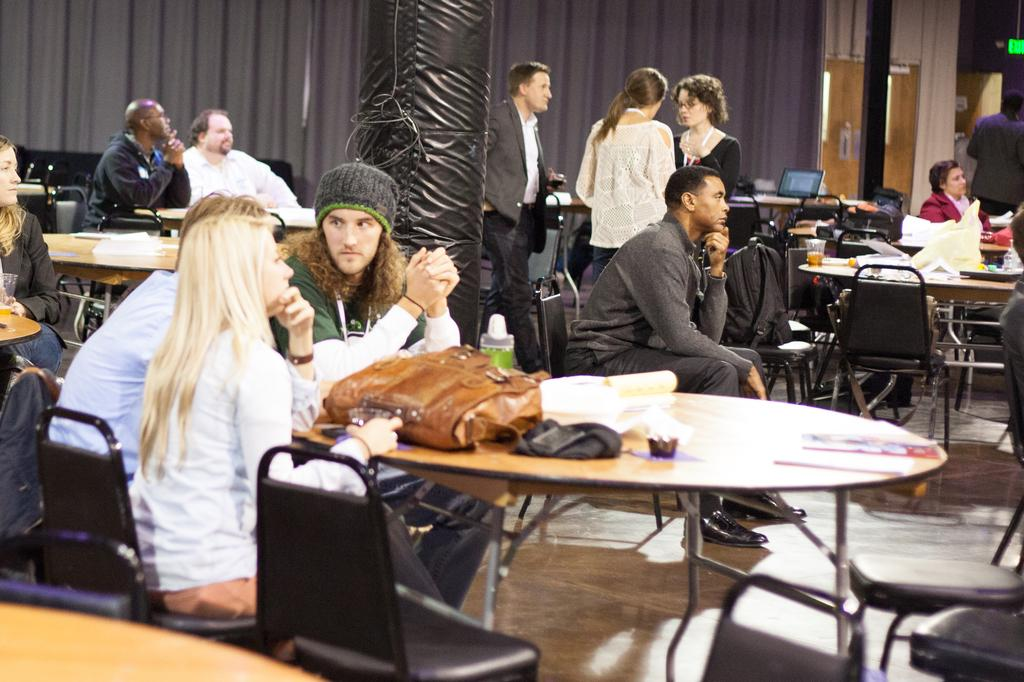What are the people in the image doing? The people in the image are sitting on chairs. What are the sitting people looking at? The sitting people are looking at something, but the image does not specify what they are looking at. Can you describe the people in the background of the image? Yes, there are people standing in the background of the image. Where are the standing people located in the image? The standing people are located in the top right area of the image. What type of lumber can be seen floating in the water near the dock in the image? There is no dock or lumber present in the image; it only features people sitting on chairs and standing around chairs. 